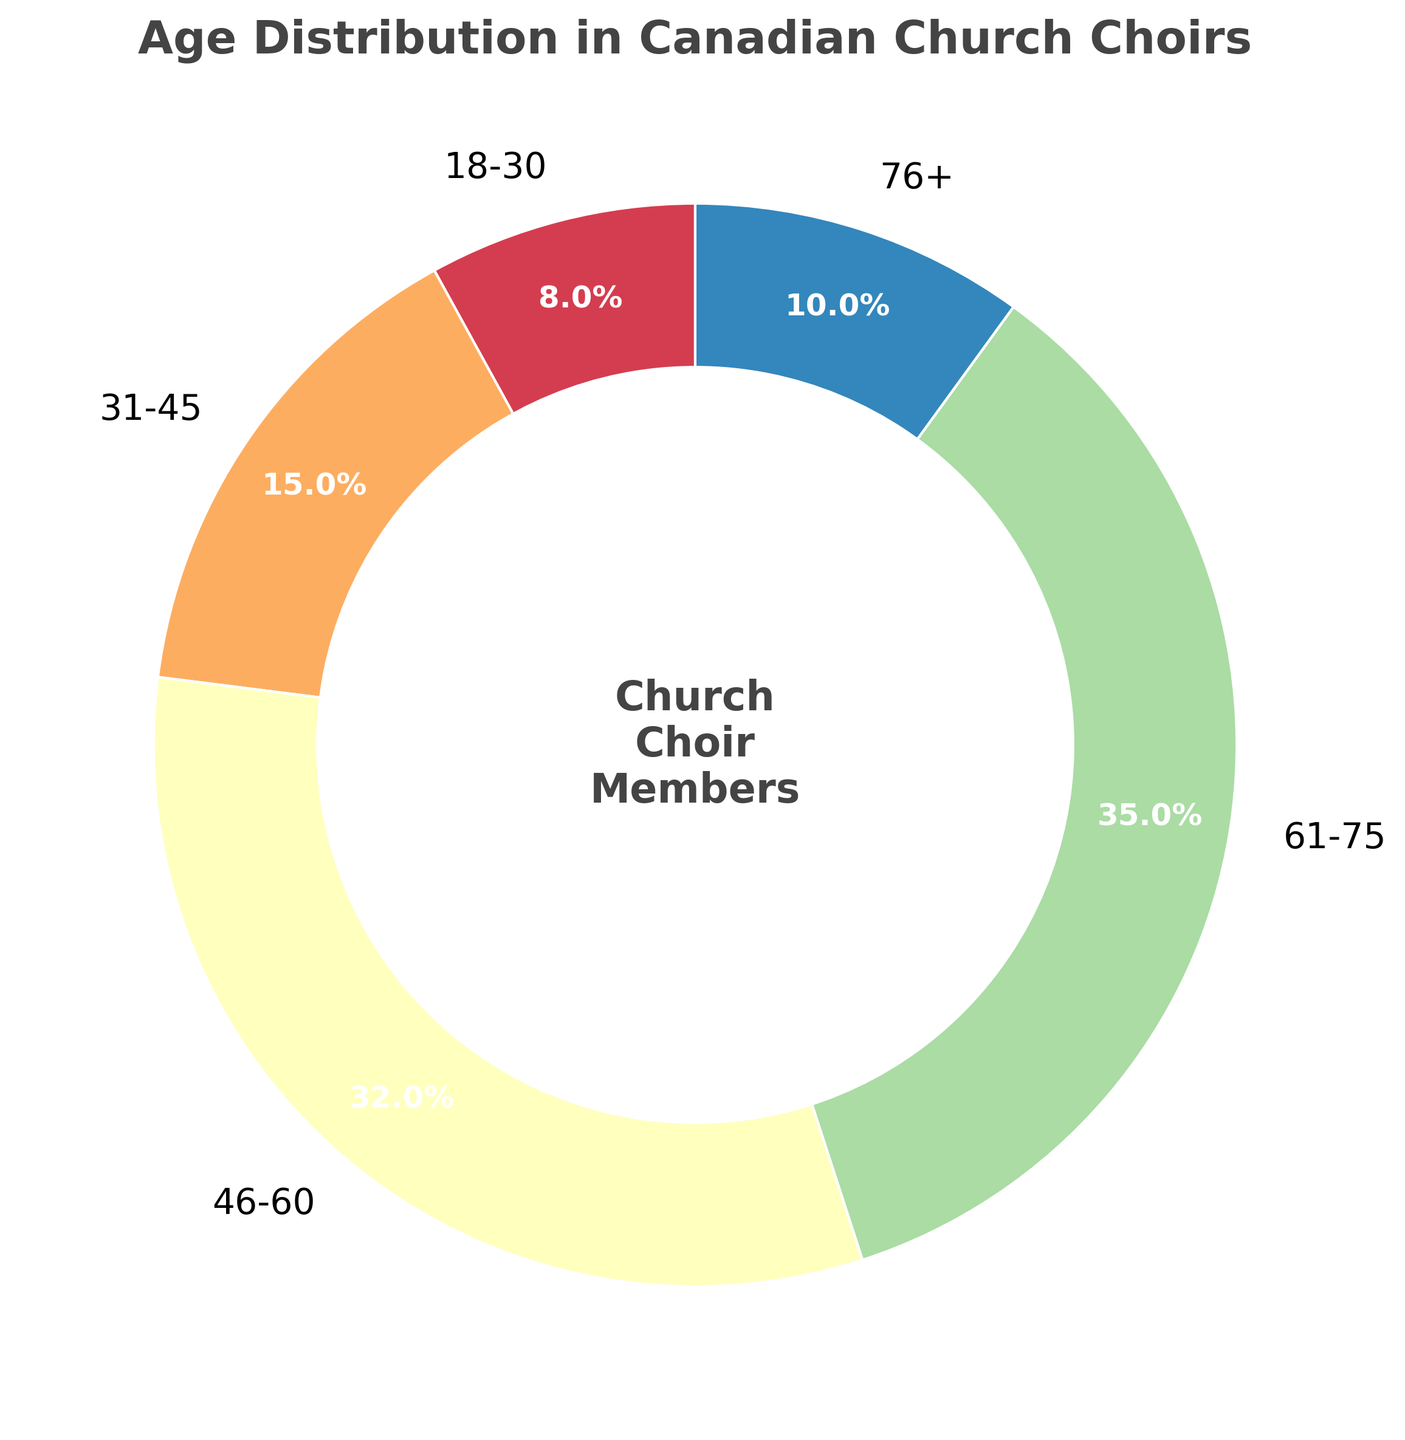What percentage of choir members are above 60 years old? Add the percentages of the age groups 61-75 and 76+ (35% + 10%).
Answer: 45% Which age group has the highest percentage of choir members? Identify the age group with the largest percentage in the pie chart. The 61-75 age group has the highest percentage at 35%.
Answer: 61-75 What is the difference in percentage between the 46-60 and 76+ age groups? Subtract the percentage of the 76+ group from the 46-60 group (32% - 10%).
Answer: 22% Are there more choir members aged 18-30 or 31-45? Compare the percentages between the 18-30 and 31-45 age groups. The 31-45 age group has a higher percentage (15%) compared to the 18-30 age group (8%).
Answer: 31-45 What is the combined percentage of choir members aged 18-45? Sum the percentages of the 18-30 and 31-45 age groups (8% + 15%).
Answer: 23% Which age group, 31-45 or 46-60, has a higher percentage of choir members? Compare the percentages between the 31-45 and 46-60 age groups. The 46-60 age group has a higher percentage (32%) compared to the 31-45 age group (15%).
Answer: 46-60 What color represents the 76+ age group in the chart? Identify the color used for the 76+ age group in the pie chart's visual attributes; it is one of the lightest segments.
Answer: Light How many age groups have a percentage greater than 30%? Count how many age groups have percentages above 30%. Both 46-60 (32%) and 61-75 (35%) meet this criterion.
Answer: 2 What's the average percentage of choir members in the 18-30, 31-45, and 46-60 age groups? Sum the percentages of these age groups (8% + 15% + 32%) and divide by 3. The average is (55% / 3).
Answer: 18.3% 